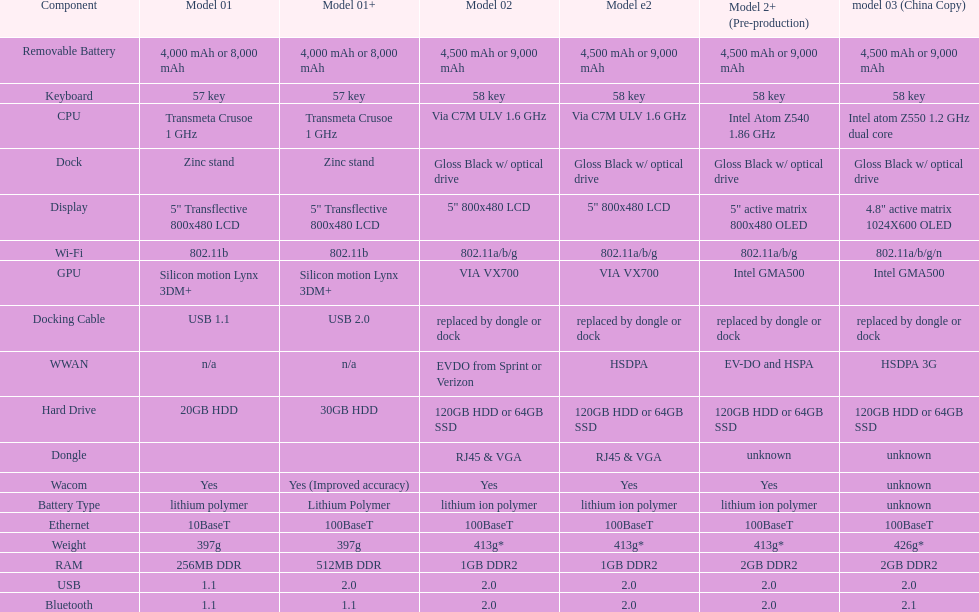Help me parse the entirety of this table. {'header': ['Component', 'Model 01', 'Model 01+', 'Model 02', 'Model e2', 'Model 2+ (Pre-production)', 'model 03 (China Copy)'], 'rows': [['Removable Battery', '4,000 mAh or 8,000 mAh', '4,000 mAh or 8,000 mAh', '4,500 mAh or 9,000 mAh', '4,500 mAh or 9,000 mAh', '4,500 mAh or 9,000 mAh', '4,500 mAh or 9,000 mAh'], ['Keyboard', '57 key', '57 key', '58 key', '58 key', '58 key', '58 key'], ['CPU', 'Transmeta Crusoe 1\xa0GHz', 'Transmeta Crusoe 1\xa0GHz', 'Via C7M ULV 1.6\xa0GHz', 'Via C7M ULV 1.6\xa0GHz', 'Intel Atom Z540 1.86\xa0GHz', 'Intel atom Z550 1.2\xa0GHz dual core'], ['Dock', 'Zinc stand', 'Zinc stand', 'Gloss Black w/ optical drive', 'Gloss Black w/ optical drive', 'Gloss Black w/ optical drive', 'Gloss Black w/ optical drive'], ['Display', '5" Transflective 800x480 LCD', '5" Transflective 800x480 LCD', '5" 800x480 LCD', '5" 800x480 LCD', '5" active matrix 800x480 OLED', '4.8" active matrix 1024X600 OLED'], ['Wi-Fi', '802.11b', '802.11b', '802.11a/b/g', '802.11a/b/g', '802.11a/b/g', '802.11a/b/g/n'], ['GPU', 'Silicon motion Lynx 3DM+', 'Silicon motion Lynx 3DM+', 'VIA VX700', 'VIA VX700', 'Intel GMA500', 'Intel GMA500'], ['Docking Cable', 'USB 1.1', 'USB 2.0', 'replaced by dongle or dock', 'replaced by dongle or dock', 'replaced by dongle or dock', 'replaced by dongle or dock'], ['WWAN', 'n/a', 'n/a', 'EVDO from Sprint or Verizon', 'HSDPA', 'EV-DO and HSPA', 'HSDPA 3G'], ['Hard Drive', '20GB HDD', '30GB HDD', '120GB HDD or 64GB SSD', '120GB HDD or 64GB SSD', '120GB HDD or 64GB SSD', '120GB HDD or 64GB SSD'], ['Dongle', '', '', 'RJ45 & VGA', 'RJ45 & VGA', 'unknown', 'unknown'], ['Wacom', 'Yes', 'Yes (Improved accuracy)', 'Yes', 'Yes', 'Yes', 'unknown'], ['Battery Type', 'lithium polymer', 'Lithium Polymer', 'lithium ion polymer', 'lithium ion polymer', 'lithium ion polymer', 'unknown'], ['Ethernet', '10BaseT', '100BaseT', '100BaseT', '100BaseT', '100BaseT', '100BaseT'], ['Weight', '397g', '397g', '413g*', '413g*', '413g*', '426g*'], ['RAM', '256MB DDR', '512MB DDR', '1GB DDR2', '1GB DDR2', '2GB DDR2', '2GB DDR2'], ['USB', '1.1', '2.0', '2.0', '2.0', '2.0', '2.0'], ['Bluetooth', '1.1', '1.1', '2.0', '2.0', '2.0', '2.1']]} What is the next highest hard drive available after the 30gb model? 64GB SSD. 